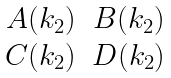Convert formula to latex. <formula><loc_0><loc_0><loc_500><loc_500>\begin{matrix} A ( k _ { 2 } ) & B ( k _ { 2 } ) \\ C ( k _ { 2 } ) & D ( k _ { 2 } ) \end{matrix}</formula> 